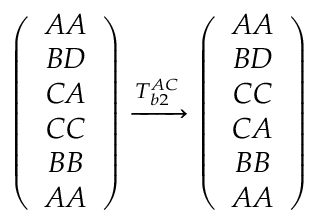Convert formula to latex. <formula><loc_0><loc_0><loc_500><loc_500>\begin{array} { r } { \left ( \begin{array} { c } { A A } \\ { B D } \\ { C A } \\ { C C } \\ { B B } \\ { A A } \end{array} \right ) \xrightarrow { T _ { b 2 } ^ { A C } } \left ( \begin{array} { c } { A A } \\ { B D } \\ { C C } \\ { C A } \\ { B B } \\ { A A } \end{array} \right ) } \end{array}</formula> 